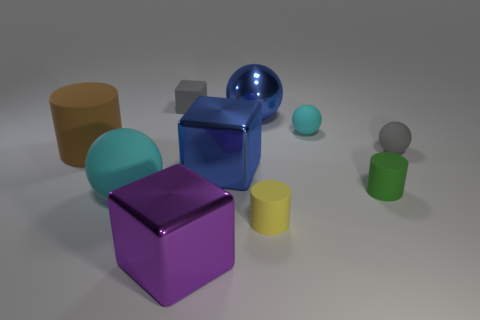Subtract all metallic cubes. How many cubes are left? 1 Subtract 2 cylinders. How many cylinders are left? 1 Subtract all cyan spheres. How many spheres are left? 2 Subtract all balls. How many objects are left? 6 Subtract all yellow cylinders. How many green cubes are left? 0 Subtract 0 cyan blocks. How many objects are left? 10 Subtract all red spheres. Subtract all purple blocks. How many spheres are left? 4 Subtract all tiny blocks. Subtract all tiny green rubber objects. How many objects are left? 8 Add 9 blue metal spheres. How many blue metal spheres are left? 10 Add 6 cyan matte objects. How many cyan matte objects exist? 8 